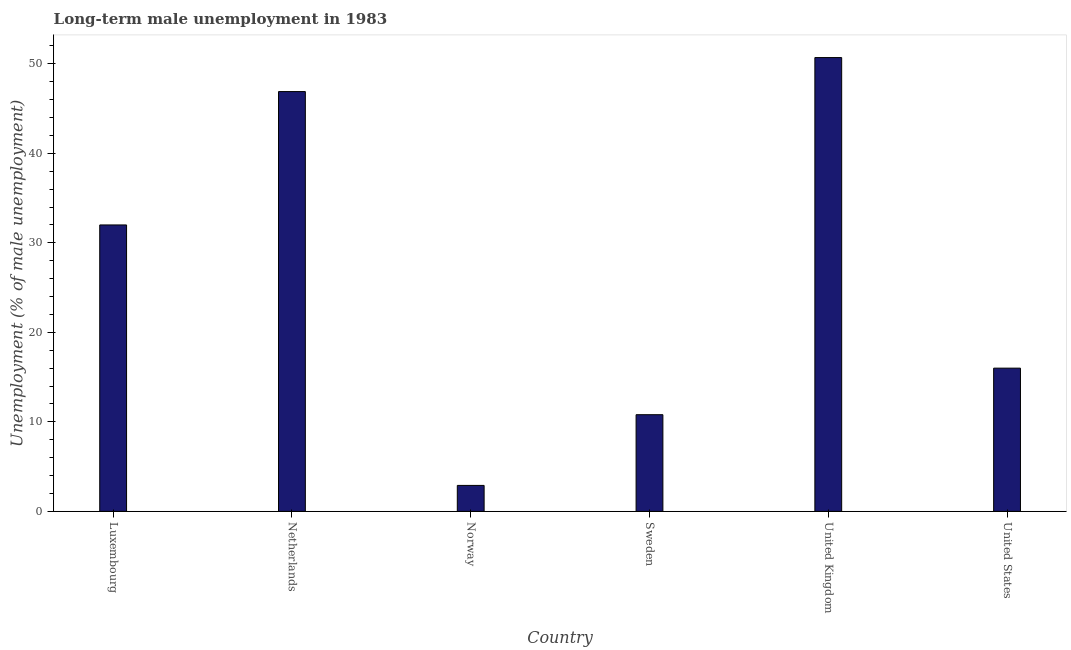Does the graph contain grids?
Your answer should be very brief. No. What is the title of the graph?
Your answer should be compact. Long-term male unemployment in 1983. What is the label or title of the Y-axis?
Make the answer very short. Unemployment (% of male unemployment). What is the long-term male unemployment in Netherlands?
Keep it short and to the point. 46.9. Across all countries, what is the maximum long-term male unemployment?
Ensure brevity in your answer.  50.7. Across all countries, what is the minimum long-term male unemployment?
Your response must be concise. 2.9. What is the sum of the long-term male unemployment?
Ensure brevity in your answer.  159.3. What is the difference between the long-term male unemployment in Sweden and United States?
Offer a terse response. -5.2. What is the average long-term male unemployment per country?
Your response must be concise. 26.55. What is the median long-term male unemployment?
Keep it short and to the point. 24. In how many countries, is the long-term male unemployment greater than 42 %?
Give a very brief answer. 2. What is the ratio of the long-term male unemployment in Norway to that in Sweden?
Your response must be concise. 0.27. What is the difference between the highest and the lowest long-term male unemployment?
Keep it short and to the point. 47.8. In how many countries, is the long-term male unemployment greater than the average long-term male unemployment taken over all countries?
Provide a succinct answer. 3. Are all the bars in the graph horizontal?
Give a very brief answer. No. How many countries are there in the graph?
Provide a short and direct response. 6. What is the difference between two consecutive major ticks on the Y-axis?
Make the answer very short. 10. What is the Unemployment (% of male unemployment) in Luxembourg?
Give a very brief answer. 32. What is the Unemployment (% of male unemployment) of Netherlands?
Ensure brevity in your answer.  46.9. What is the Unemployment (% of male unemployment) of Norway?
Provide a succinct answer. 2.9. What is the Unemployment (% of male unemployment) of Sweden?
Your response must be concise. 10.8. What is the Unemployment (% of male unemployment) of United Kingdom?
Provide a succinct answer. 50.7. What is the Unemployment (% of male unemployment) of United States?
Your response must be concise. 16. What is the difference between the Unemployment (% of male unemployment) in Luxembourg and Netherlands?
Provide a short and direct response. -14.9. What is the difference between the Unemployment (% of male unemployment) in Luxembourg and Norway?
Keep it short and to the point. 29.1. What is the difference between the Unemployment (% of male unemployment) in Luxembourg and Sweden?
Ensure brevity in your answer.  21.2. What is the difference between the Unemployment (% of male unemployment) in Luxembourg and United Kingdom?
Your response must be concise. -18.7. What is the difference between the Unemployment (% of male unemployment) in Netherlands and Sweden?
Your answer should be very brief. 36.1. What is the difference between the Unemployment (% of male unemployment) in Netherlands and United Kingdom?
Provide a short and direct response. -3.8. What is the difference between the Unemployment (% of male unemployment) in Netherlands and United States?
Your answer should be compact. 30.9. What is the difference between the Unemployment (% of male unemployment) in Norway and United Kingdom?
Your answer should be compact. -47.8. What is the difference between the Unemployment (% of male unemployment) in Norway and United States?
Keep it short and to the point. -13.1. What is the difference between the Unemployment (% of male unemployment) in Sweden and United Kingdom?
Give a very brief answer. -39.9. What is the difference between the Unemployment (% of male unemployment) in United Kingdom and United States?
Your answer should be compact. 34.7. What is the ratio of the Unemployment (% of male unemployment) in Luxembourg to that in Netherlands?
Offer a terse response. 0.68. What is the ratio of the Unemployment (% of male unemployment) in Luxembourg to that in Norway?
Your answer should be compact. 11.03. What is the ratio of the Unemployment (% of male unemployment) in Luxembourg to that in Sweden?
Provide a short and direct response. 2.96. What is the ratio of the Unemployment (% of male unemployment) in Luxembourg to that in United Kingdom?
Your answer should be very brief. 0.63. What is the ratio of the Unemployment (% of male unemployment) in Netherlands to that in Norway?
Offer a very short reply. 16.17. What is the ratio of the Unemployment (% of male unemployment) in Netherlands to that in Sweden?
Make the answer very short. 4.34. What is the ratio of the Unemployment (% of male unemployment) in Netherlands to that in United Kingdom?
Make the answer very short. 0.93. What is the ratio of the Unemployment (% of male unemployment) in Netherlands to that in United States?
Provide a short and direct response. 2.93. What is the ratio of the Unemployment (% of male unemployment) in Norway to that in Sweden?
Keep it short and to the point. 0.27. What is the ratio of the Unemployment (% of male unemployment) in Norway to that in United Kingdom?
Your response must be concise. 0.06. What is the ratio of the Unemployment (% of male unemployment) in Norway to that in United States?
Your response must be concise. 0.18. What is the ratio of the Unemployment (% of male unemployment) in Sweden to that in United Kingdom?
Offer a very short reply. 0.21. What is the ratio of the Unemployment (% of male unemployment) in Sweden to that in United States?
Provide a short and direct response. 0.68. What is the ratio of the Unemployment (% of male unemployment) in United Kingdom to that in United States?
Offer a very short reply. 3.17. 